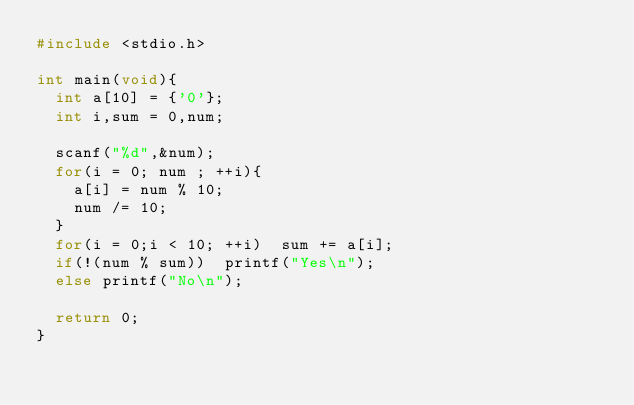<code> <loc_0><loc_0><loc_500><loc_500><_C_>#include <stdio.h>

int main(void){
  int a[10] = {'0'};
  int i,sum = 0,num;
  
  scanf("%d",&num);
  for(i = 0; num ; ++i){
    a[i] = num % 10;
    num /= 10;
  }
  for(i = 0;i < 10; ++i)	sum += a[i];
  if(!(num % sum))	printf("Yes\n");
  else printf("No\n");
  
  return 0;
}</code> 